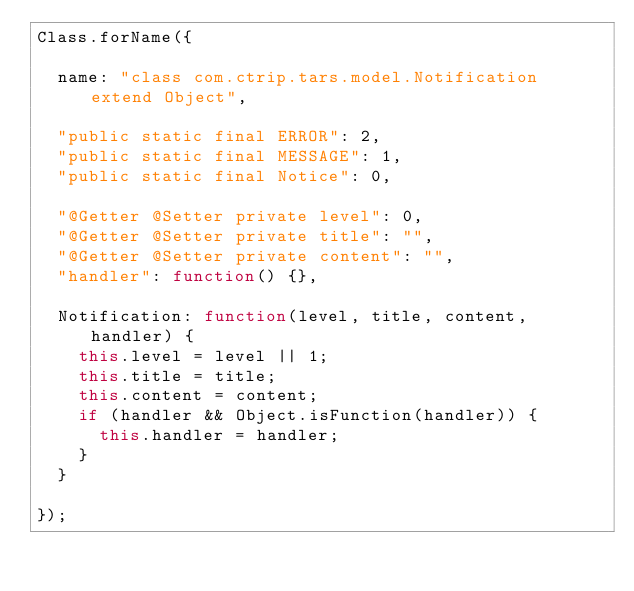<code> <loc_0><loc_0><loc_500><loc_500><_JavaScript_>Class.forName({

  name: "class com.ctrip.tars.model.Notification extend Object",

  "public static final ERROR": 2,
  "public static final MESSAGE": 1,
  "public static final Notice": 0,

  "@Getter @Setter private level": 0,
  "@Getter @Setter private title": "",
  "@Getter @Setter private content": "",
  "handler": function() {},

  Notification: function(level, title, content, handler) {
    this.level = level || 1;
    this.title = title;
    this.content = content;
    if (handler && Object.isFunction(handler)) {
      this.handler = handler;
    }
  }

});

</code> 